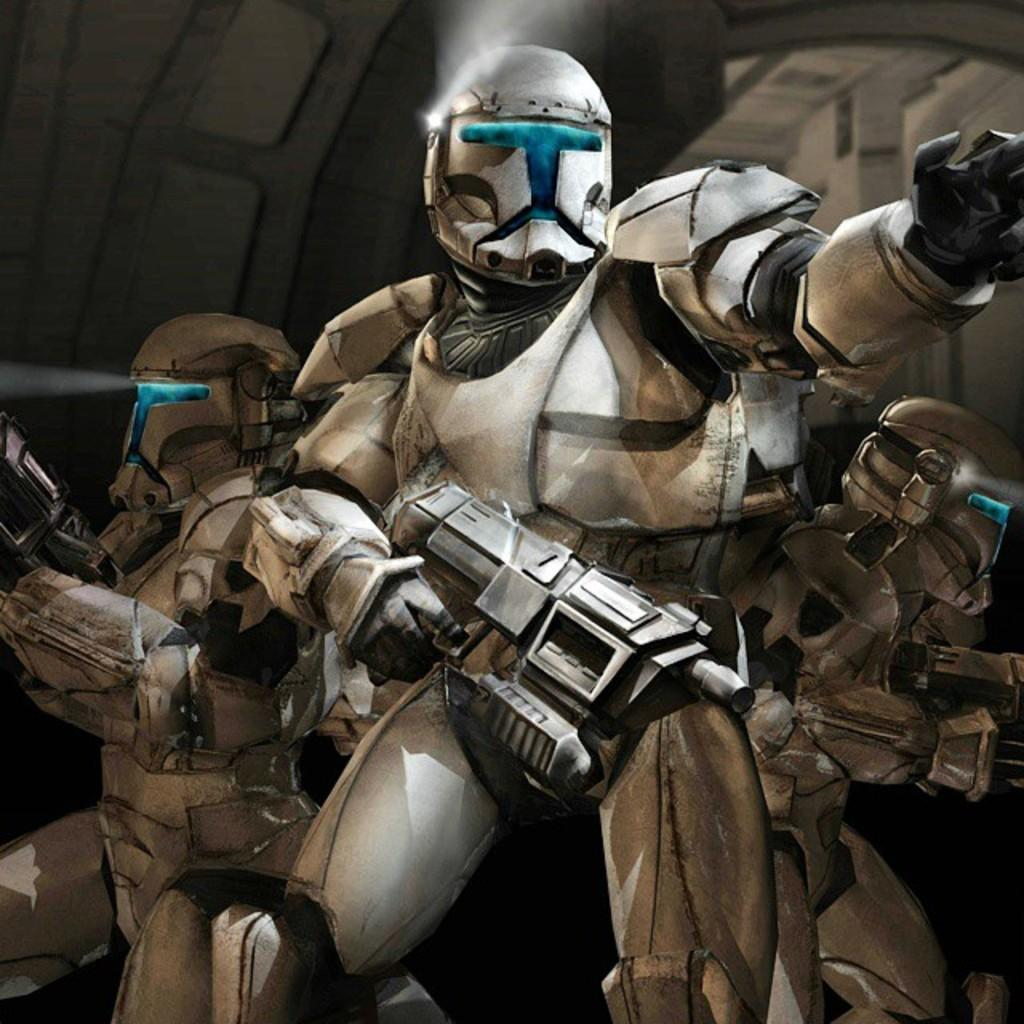What type of objects are present in the image? There are robots in the image. What are the robots holding in their hands? The robots are holding guns. Where is the shelf located in the image? There is no shelf present in the image. What type of pin is the robot wearing in the image? There are no pins visible on the robots in the image. 